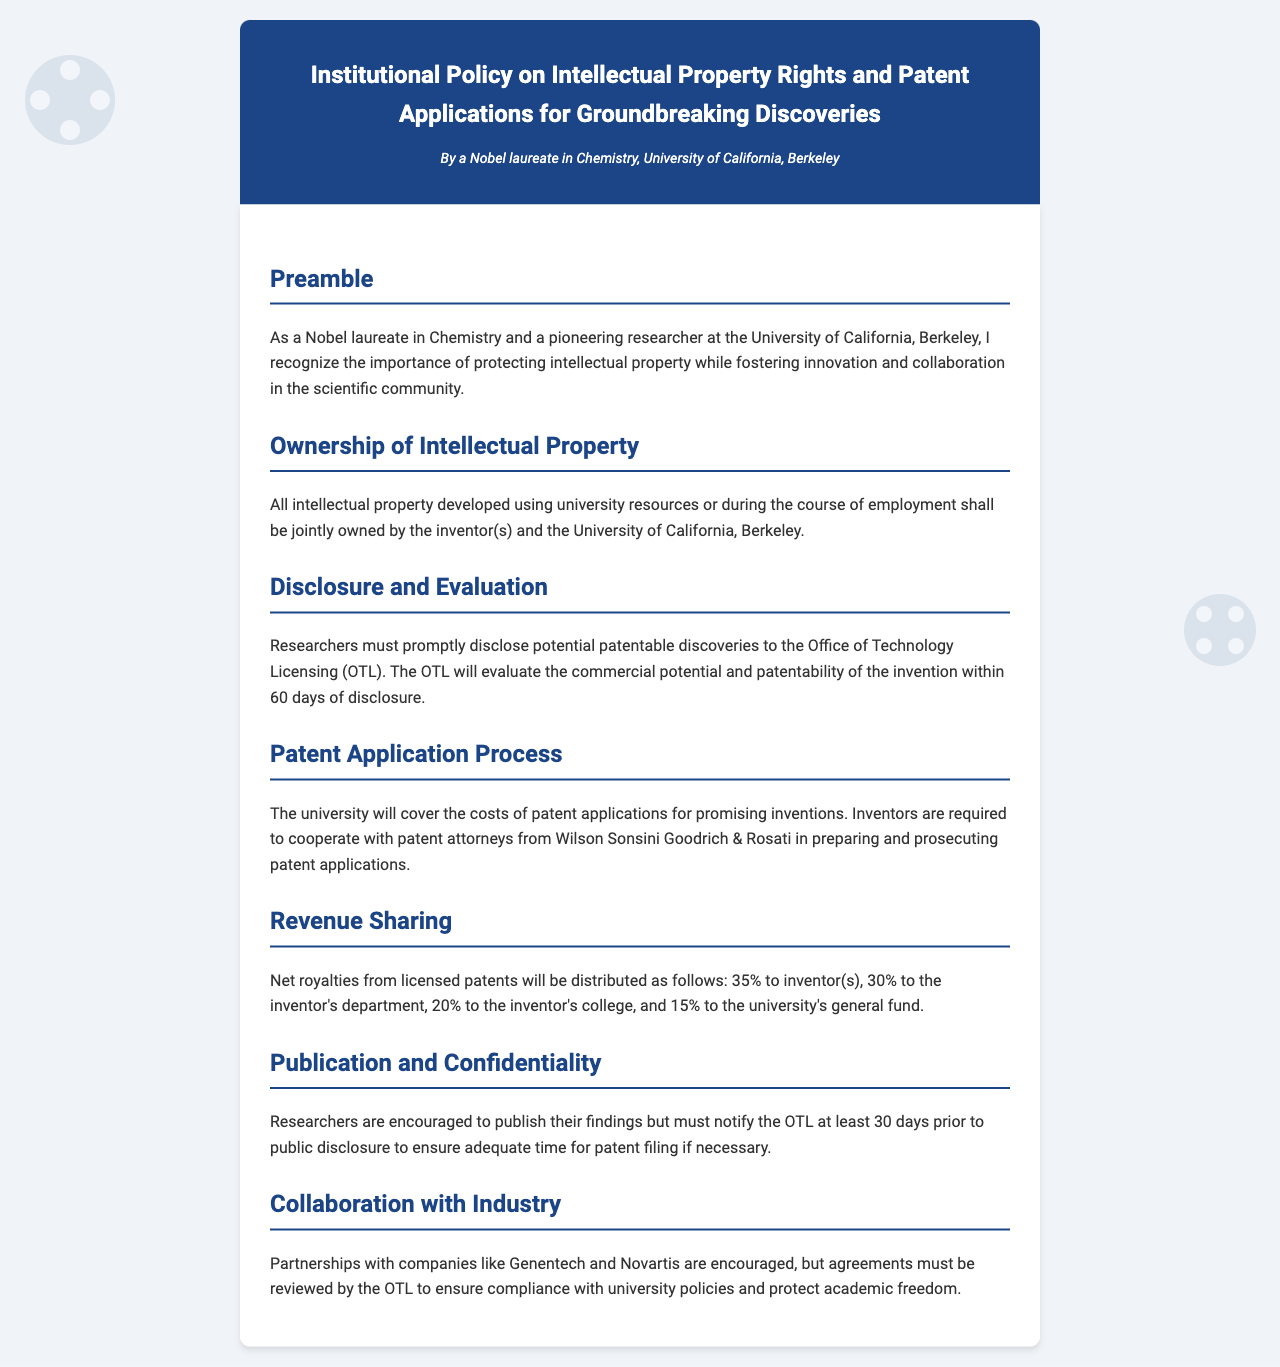What is the title of the document? The title is explicitly mentioned at the beginning of the document.
Answer: Institutional Policy on Intellectual Property Rights and Patent Applications for Groundbreaking Discoveries Who is the author of the document? The author is indicated in the header section of the document.
Answer: A Nobel laureate in Chemistry, University of California, Berkeley What is the period for the Office of Technology Licensing to evaluate inventions? The evaluation period is stated in the Disclosure and Evaluation section of the document.
Answer: 60 days What percentage of net royalties do inventor(s) receive? This information is found under the Revenue Sharing section of the document.
Answer: 35% What must researchers do before public disclosure? The policy outlines specific actions required before publication under the Publication and Confidentiality section.
Answer: Notify the OTL at least 30 days prior Which company partnerships are encouraged? This detail is mentioned in the Collaboration with Industry section.
Answer: Genentech and Novartis What costs will the university cover? This information is found under the Patent Application Process section of the document.
Answer: Costs of patent applications What is the sharing percentage for the inventor’s department? This figure is located in the Revenue Sharing section, detailing the distribution of royalties.
Answer: 30% 